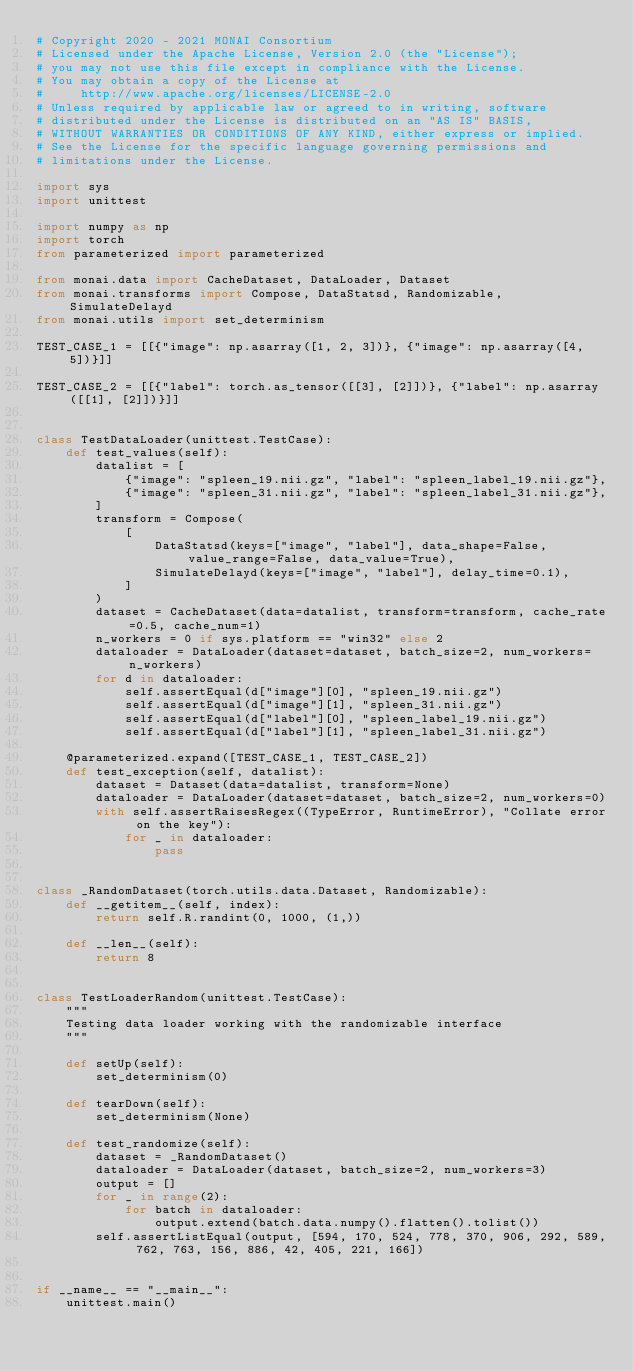Convert code to text. <code><loc_0><loc_0><loc_500><loc_500><_Python_># Copyright 2020 - 2021 MONAI Consortium
# Licensed under the Apache License, Version 2.0 (the "License");
# you may not use this file except in compliance with the License.
# You may obtain a copy of the License at
#     http://www.apache.org/licenses/LICENSE-2.0
# Unless required by applicable law or agreed to in writing, software
# distributed under the License is distributed on an "AS IS" BASIS,
# WITHOUT WARRANTIES OR CONDITIONS OF ANY KIND, either express or implied.
# See the License for the specific language governing permissions and
# limitations under the License.

import sys
import unittest

import numpy as np
import torch
from parameterized import parameterized

from monai.data import CacheDataset, DataLoader, Dataset
from monai.transforms import Compose, DataStatsd, Randomizable, SimulateDelayd
from monai.utils import set_determinism

TEST_CASE_1 = [[{"image": np.asarray([1, 2, 3])}, {"image": np.asarray([4, 5])}]]

TEST_CASE_2 = [[{"label": torch.as_tensor([[3], [2]])}, {"label": np.asarray([[1], [2]])}]]


class TestDataLoader(unittest.TestCase):
    def test_values(self):
        datalist = [
            {"image": "spleen_19.nii.gz", "label": "spleen_label_19.nii.gz"},
            {"image": "spleen_31.nii.gz", "label": "spleen_label_31.nii.gz"},
        ]
        transform = Compose(
            [
                DataStatsd(keys=["image", "label"], data_shape=False, value_range=False, data_value=True),
                SimulateDelayd(keys=["image", "label"], delay_time=0.1),
            ]
        )
        dataset = CacheDataset(data=datalist, transform=transform, cache_rate=0.5, cache_num=1)
        n_workers = 0 if sys.platform == "win32" else 2
        dataloader = DataLoader(dataset=dataset, batch_size=2, num_workers=n_workers)
        for d in dataloader:
            self.assertEqual(d["image"][0], "spleen_19.nii.gz")
            self.assertEqual(d["image"][1], "spleen_31.nii.gz")
            self.assertEqual(d["label"][0], "spleen_label_19.nii.gz")
            self.assertEqual(d["label"][1], "spleen_label_31.nii.gz")

    @parameterized.expand([TEST_CASE_1, TEST_CASE_2])
    def test_exception(self, datalist):
        dataset = Dataset(data=datalist, transform=None)
        dataloader = DataLoader(dataset=dataset, batch_size=2, num_workers=0)
        with self.assertRaisesRegex((TypeError, RuntimeError), "Collate error on the key"):
            for _ in dataloader:
                pass


class _RandomDataset(torch.utils.data.Dataset, Randomizable):
    def __getitem__(self, index):
        return self.R.randint(0, 1000, (1,))

    def __len__(self):
        return 8


class TestLoaderRandom(unittest.TestCase):
    """
    Testing data loader working with the randomizable interface
    """

    def setUp(self):
        set_determinism(0)

    def tearDown(self):
        set_determinism(None)

    def test_randomize(self):
        dataset = _RandomDataset()
        dataloader = DataLoader(dataset, batch_size=2, num_workers=3)
        output = []
        for _ in range(2):
            for batch in dataloader:
                output.extend(batch.data.numpy().flatten().tolist())
        self.assertListEqual(output, [594, 170, 524, 778, 370, 906, 292, 589, 762, 763, 156, 886, 42, 405, 221, 166])


if __name__ == "__main__":
    unittest.main()
</code> 